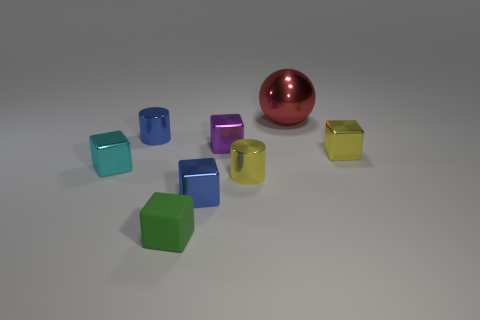Is there anything else that is the same material as the tiny green thing?
Your response must be concise. No. The purple shiny thing has what shape?
Give a very brief answer. Cube. There is a cylinder in front of the small cube behind the small yellow object that is on the right side of the ball; what is it made of?
Your answer should be compact. Metal. Are there more yellow metal things that are to the left of the yellow metallic cylinder than small blue spheres?
Keep it short and to the point. No. What material is the purple object that is the same size as the yellow metallic cube?
Give a very brief answer. Metal. Is there a gray object that has the same size as the green rubber cube?
Keep it short and to the point. No. There is a blue thing behind the yellow metal cylinder; what size is it?
Your answer should be very brief. Small. How big is the blue cylinder?
Offer a terse response. Small. What number of blocks are either cyan objects or small purple metal objects?
Provide a succinct answer. 2. What is the size of the purple block that is the same material as the small yellow cylinder?
Provide a short and direct response. Small. 